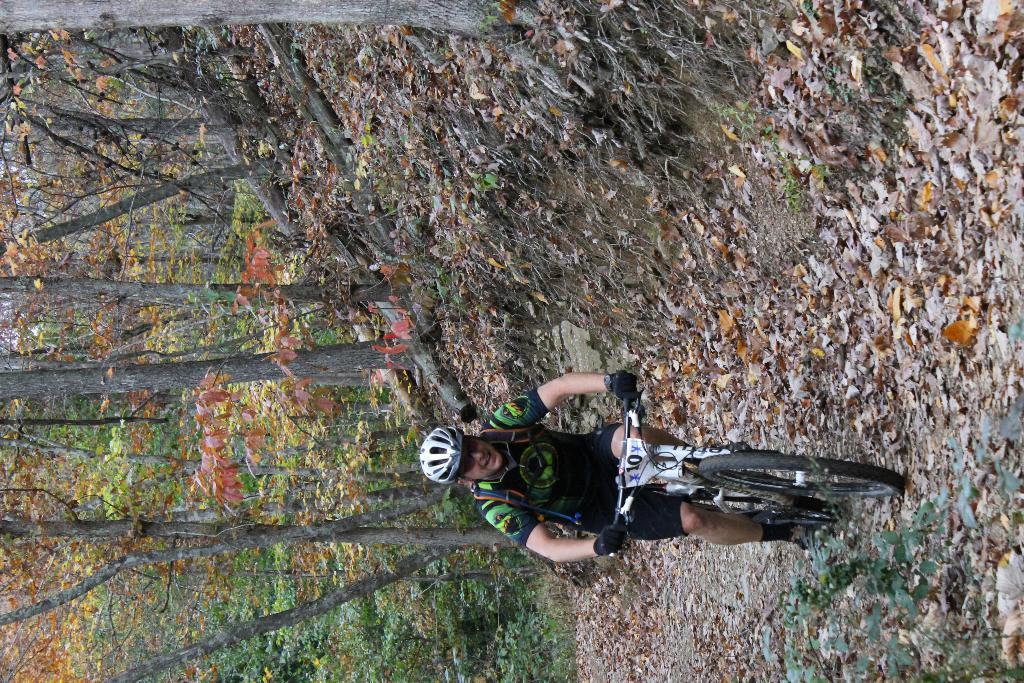Describe this image in one or two sentences. In this picture we can see a man is riding a bicycle. Behind the man, there are dried leaves and trees. At the bottom right corner of the image, there are plants. 